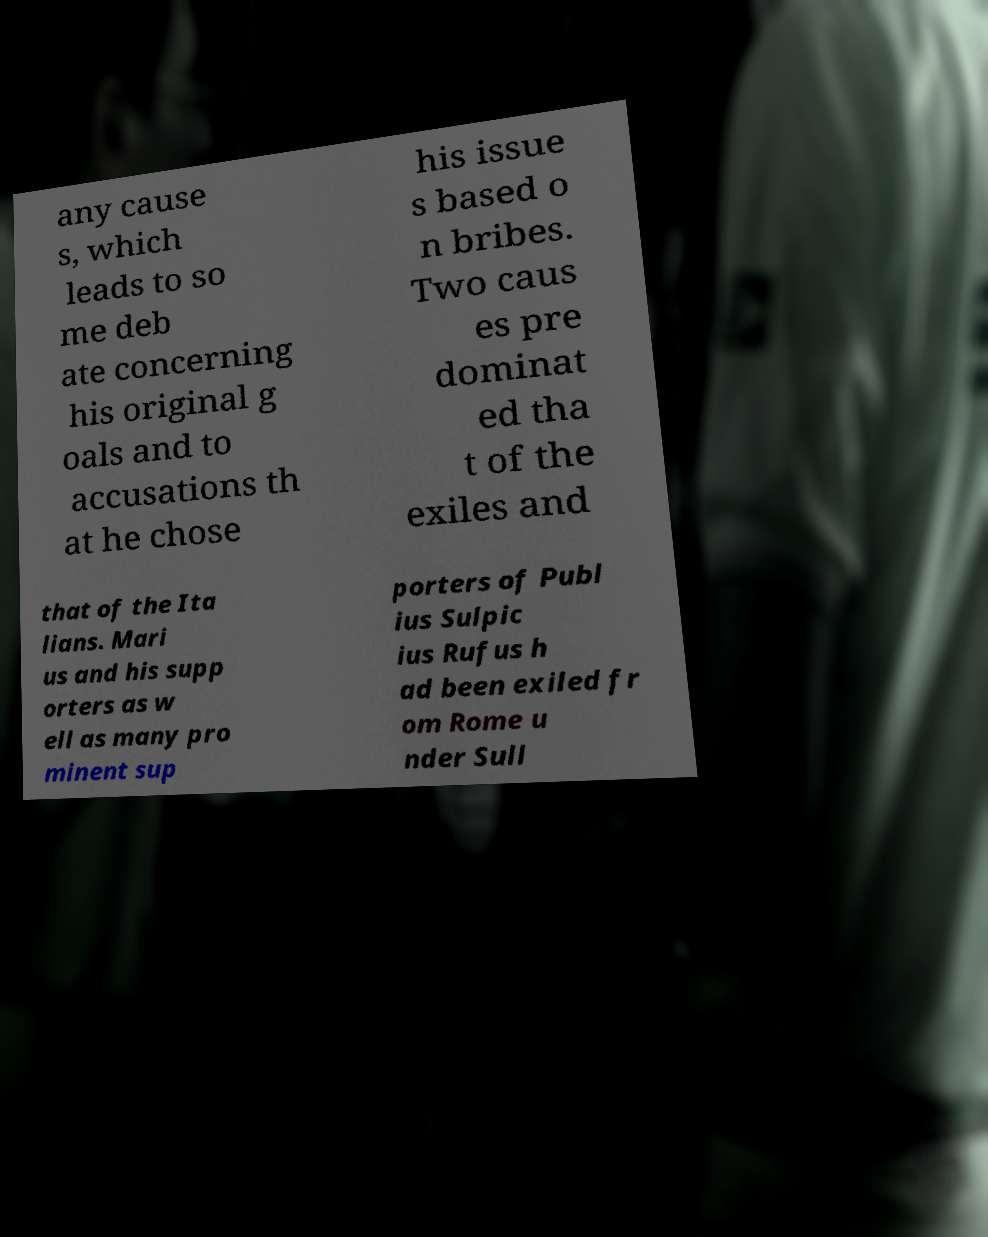What messages or text are displayed in this image? I need them in a readable, typed format. any cause s, which leads to so me deb ate concerning his original g oals and to accusations th at he chose his issue s based o n bribes. Two caus es pre dominat ed tha t of the exiles and that of the Ita lians. Mari us and his supp orters as w ell as many pro minent sup porters of Publ ius Sulpic ius Rufus h ad been exiled fr om Rome u nder Sull 